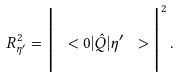Convert formula to latex. <formula><loc_0><loc_0><loc_500><loc_500>R ^ { 2 } _ { \eta ^ { \prime } } = \Big { | } \ < 0 | \hat { Q } | { \eta ^ { \prime } } \ > \Big { | } ^ { 2 } \, .</formula> 